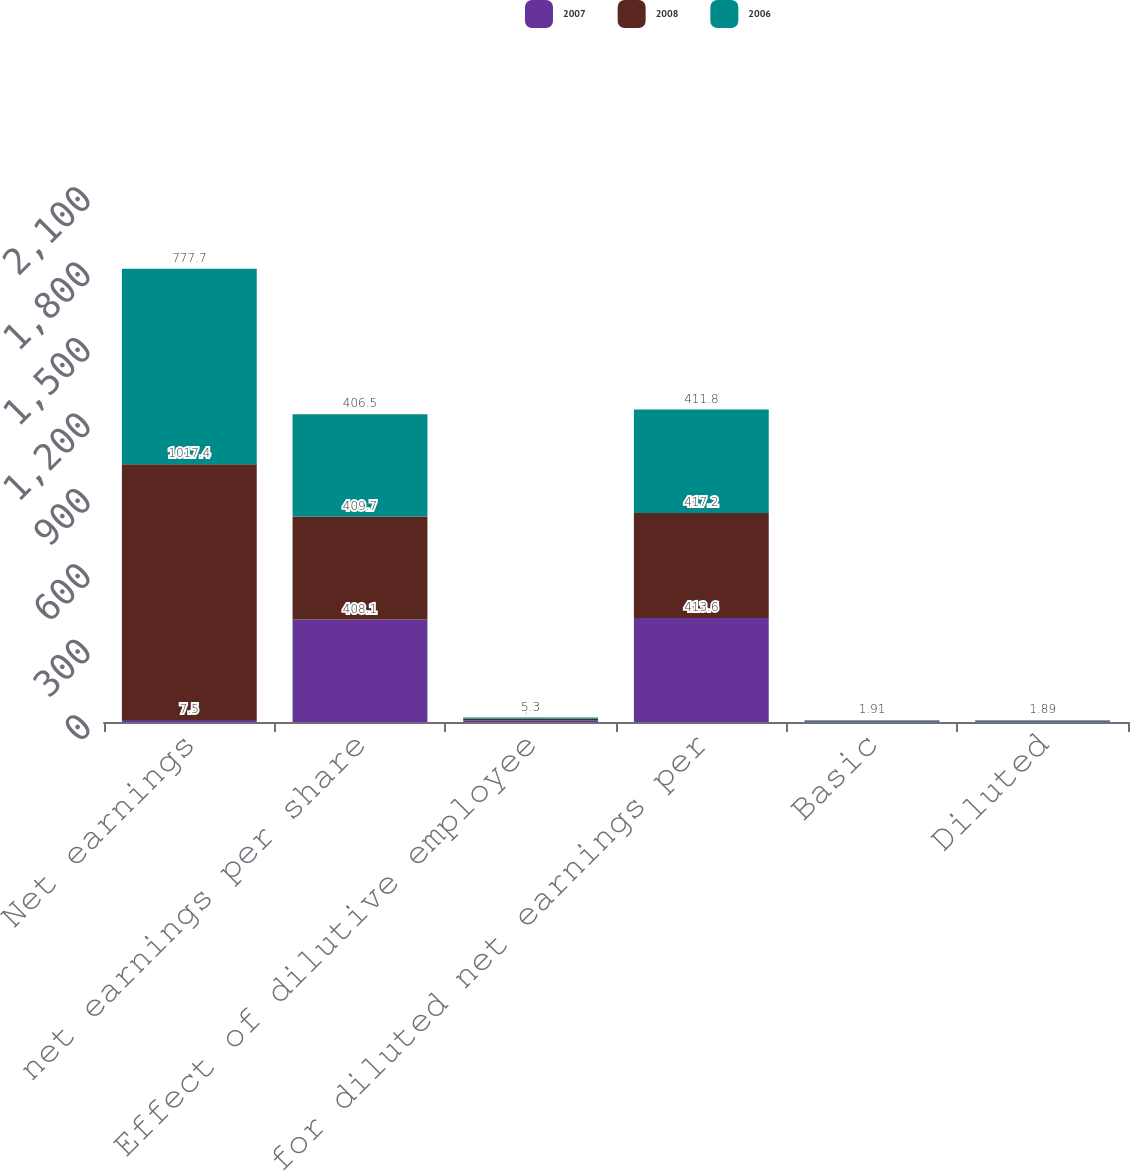<chart> <loc_0><loc_0><loc_500><loc_500><stacked_bar_chart><ecel><fcel>Net earnings<fcel>net earnings per share<fcel>Effect of dilutive employee<fcel>for diluted net earnings per<fcel>Basic<fcel>Diluted<nl><fcel>2007<fcel>7.5<fcel>408.1<fcel>5.5<fcel>413.6<fcel>2.81<fcel>2.78<nl><fcel>2008<fcel>1017.4<fcel>409.7<fcel>7.5<fcel>417.2<fcel>2.48<fcel>2.44<nl><fcel>2006<fcel>777.7<fcel>406.5<fcel>5.3<fcel>411.8<fcel>1.91<fcel>1.89<nl></chart> 